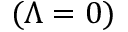<formula> <loc_0><loc_0><loc_500><loc_500>( \Lambda = 0 )</formula> 